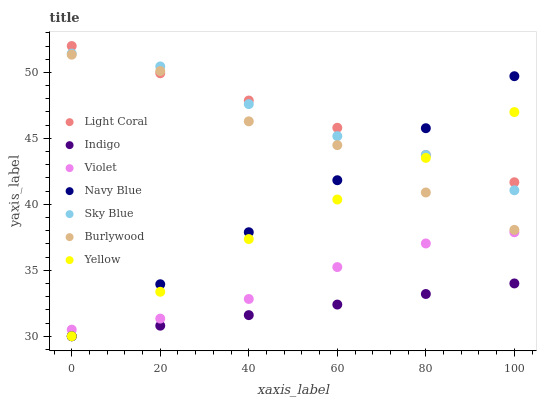Does Indigo have the minimum area under the curve?
Answer yes or no. Yes. Does Light Coral have the maximum area under the curve?
Answer yes or no. Yes. Does Burlywood have the minimum area under the curve?
Answer yes or no. No. Does Burlywood have the maximum area under the curve?
Answer yes or no. No. Is Navy Blue the smoothest?
Answer yes or no. Yes. Is Burlywood the roughest?
Answer yes or no. Yes. Is Burlywood the smoothest?
Answer yes or no. No. Is Navy Blue the roughest?
Answer yes or no. No. Does Indigo have the lowest value?
Answer yes or no. Yes. Does Burlywood have the lowest value?
Answer yes or no. No. Does Light Coral have the highest value?
Answer yes or no. Yes. Does Burlywood have the highest value?
Answer yes or no. No. Is Indigo less than Burlywood?
Answer yes or no. Yes. Is Burlywood greater than Violet?
Answer yes or no. Yes. Does Yellow intersect Navy Blue?
Answer yes or no. Yes. Is Yellow less than Navy Blue?
Answer yes or no. No. Is Yellow greater than Navy Blue?
Answer yes or no. No. Does Indigo intersect Burlywood?
Answer yes or no. No. 